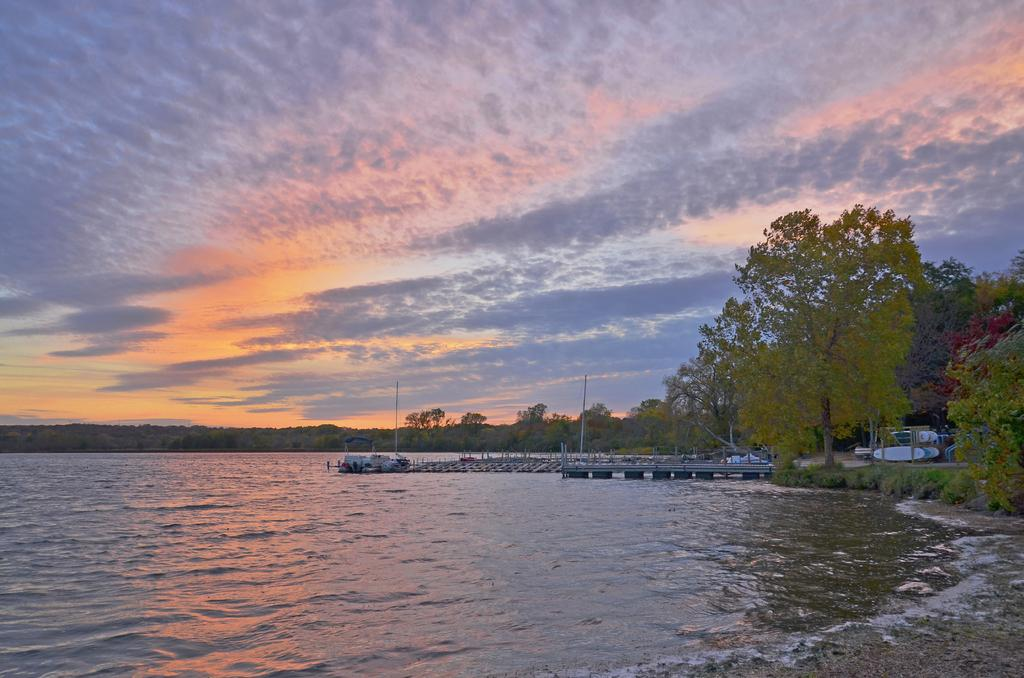What is the primary element visible in the image? There is water in the image. What type of natural vegetation can be seen in the image? There are trees in the image. What structures are present in the image? There are poles in the image. What is visible above the water and trees in the image? The sky is visible in the image. Where is the lamp located in the image? There is no lamp present in the image. What type of party is taking place in the image? There is no party depicted in the image. 